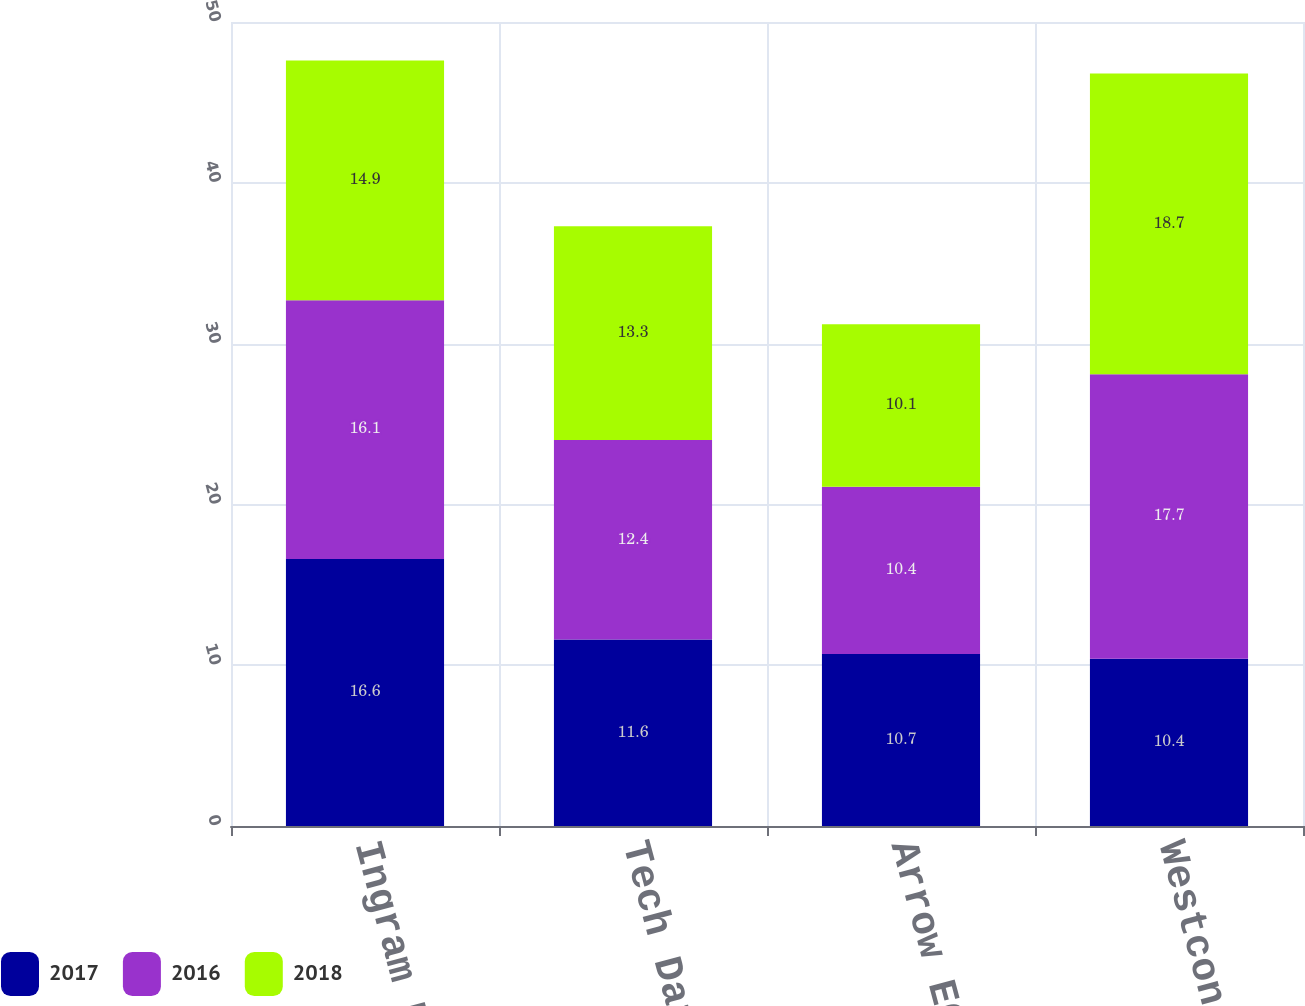Convert chart to OTSL. <chart><loc_0><loc_0><loc_500><loc_500><stacked_bar_chart><ecel><fcel>Ingram Micro Inc<fcel>Tech Data 1<fcel>Arrow ECS<fcel>Westcon Group Inc 2<nl><fcel>2017<fcel>16.6<fcel>11.6<fcel>10.7<fcel>10.4<nl><fcel>2016<fcel>16.1<fcel>12.4<fcel>10.4<fcel>17.7<nl><fcel>2018<fcel>14.9<fcel>13.3<fcel>10.1<fcel>18.7<nl></chart> 